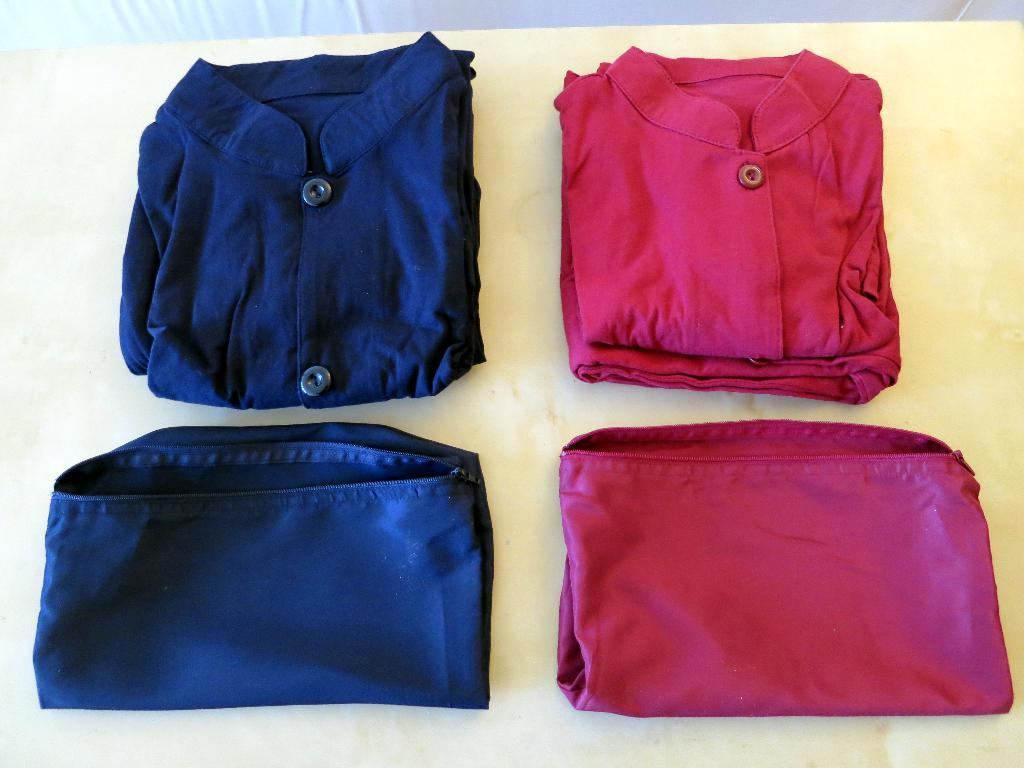What is placed on the table in the image? There are clothes on a table in the image. What type of event is taking place in the bedroom in the image? There is no bedroom or event present in the image; it only shows clothes on a table. 